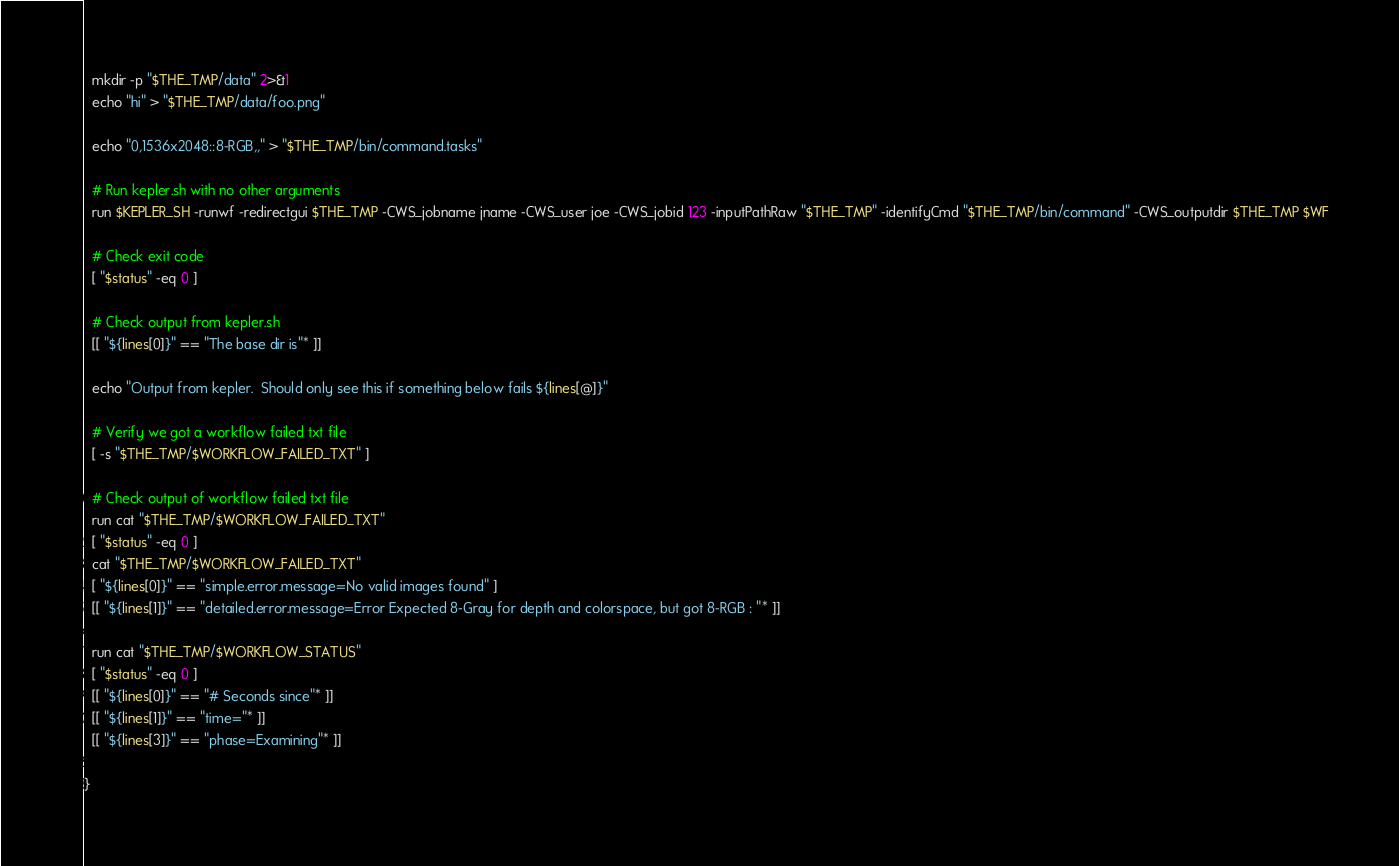<code> <loc_0><loc_0><loc_500><loc_500><_Bash_>  mkdir -p "$THE_TMP/data" 2>&1
  echo "hi" > "$THE_TMP/data/foo.png"

  echo "0,1536x2048::8-RGB,," > "$THE_TMP/bin/command.tasks"

  # Run kepler.sh with no other arguments
  run $KEPLER_SH -runwf -redirectgui $THE_TMP -CWS_jobname jname -CWS_user joe -CWS_jobid 123 -inputPathRaw "$THE_TMP" -identifyCmd "$THE_TMP/bin/command" -CWS_outputdir $THE_TMP $WF

  # Check exit code
  [ "$status" -eq 0 ]

  # Check output from kepler.sh
  [[ "${lines[0]}" == "The base dir is"* ]]

  echo "Output from kepler.  Should only see this if something below fails ${lines[@]}"

  # Verify we got a workflow failed txt file
  [ -s "$THE_TMP/$WORKFLOW_FAILED_TXT" ]

  # Check output of workflow failed txt file
  run cat "$THE_TMP/$WORKFLOW_FAILED_TXT"
  [ "$status" -eq 0 ]
  cat "$THE_TMP/$WORKFLOW_FAILED_TXT"
  [ "${lines[0]}" == "simple.error.message=No valid images found" ]
  [[ "${lines[1]}" == "detailed.error.message=Error Expected 8-Gray for depth and colorspace, but got 8-RGB : "* ]]

  run cat "$THE_TMP/$WORKFLOW_STATUS"
  [ "$status" -eq 0 ]
  [[ "${lines[0]}" == "# Seconds since"* ]]
  [[ "${lines[1]}" == "time="* ]]
  [[ "${lines[3]}" == "phase=Examining"* ]]

}


</code> 